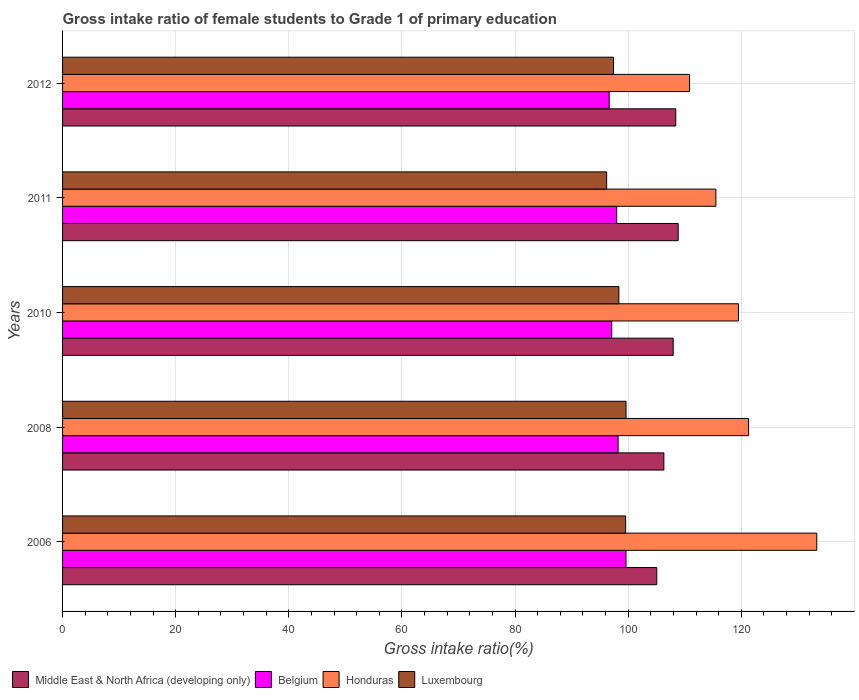How many groups of bars are there?
Provide a succinct answer. 5. Are the number of bars per tick equal to the number of legend labels?
Ensure brevity in your answer.  Yes. How many bars are there on the 2nd tick from the bottom?
Your response must be concise. 4. What is the label of the 5th group of bars from the top?
Offer a terse response. 2006. In how many cases, is the number of bars for a given year not equal to the number of legend labels?
Your answer should be compact. 0. What is the gross intake ratio in Middle East & North Africa (developing only) in 2010?
Provide a succinct answer. 107.95. Across all years, what is the maximum gross intake ratio in Honduras?
Keep it short and to the point. 133.33. Across all years, what is the minimum gross intake ratio in Luxembourg?
Offer a terse response. 96.19. In which year was the gross intake ratio in Middle East & North Africa (developing only) minimum?
Provide a succinct answer. 2006. What is the total gross intake ratio in Honduras in the graph?
Your answer should be compact. 600.43. What is the difference between the gross intake ratio in Luxembourg in 2006 and that in 2011?
Your response must be concise. 3.35. What is the difference between the gross intake ratio in Belgium in 2008 and the gross intake ratio in Honduras in 2012?
Provide a short and direct response. -12.63. What is the average gross intake ratio in Luxembourg per year?
Keep it short and to the point. 98.21. In the year 2006, what is the difference between the gross intake ratio in Belgium and gross intake ratio in Honduras?
Make the answer very short. -33.73. In how many years, is the gross intake ratio in Luxembourg greater than 92 %?
Keep it short and to the point. 5. What is the ratio of the gross intake ratio in Luxembourg in 2008 to that in 2011?
Keep it short and to the point. 1.04. Is the difference between the gross intake ratio in Belgium in 2010 and 2012 greater than the difference between the gross intake ratio in Honduras in 2010 and 2012?
Provide a short and direct response. No. What is the difference between the highest and the second highest gross intake ratio in Luxembourg?
Keep it short and to the point. 0.07. What is the difference between the highest and the lowest gross intake ratio in Belgium?
Your answer should be compact. 2.97. In how many years, is the gross intake ratio in Middle East & North Africa (developing only) greater than the average gross intake ratio in Middle East & North Africa (developing only) taken over all years?
Provide a short and direct response. 3. Is the sum of the gross intake ratio in Luxembourg in 2008 and 2010 greater than the maximum gross intake ratio in Belgium across all years?
Your answer should be very brief. Yes. What does the 1st bar from the top in 2006 represents?
Provide a short and direct response. Luxembourg. What does the 1st bar from the bottom in 2012 represents?
Offer a terse response. Middle East & North Africa (developing only). Is it the case that in every year, the sum of the gross intake ratio in Middle East & North Africa (developing only) and gross intake ratio in Honduras is greater than the gross intake ratio in Belgium?
Your answer should be compact. Yes. How many bars are there?
Your answer should be very brief. 20. What is the difference between two consecutive major ticks on the X-axis?
Give a very brief answer. 20. Does the graph contain grids?
Make the answer very short. Yes. How many legend labels are there?
Provide a short and direct response. 4. How are the legend labels stacked?
Your response must be concise. Horizontal. What is the title of the graph?
Make the answer very short. Gross intake ratio of female students to Grade 1 of primary education. What is the label or title of the X-axis?
Your answer should be compact. Gross intake ratio(%). What is the Gross intake ratio(%) of Middle East & North Africa (developing only) in 2006?
Keep it short and to the point. 105.05. What is the Gross intake ratio(%) in Belgium in 2006?
Provide a succinct answer. 99.61. What is the Gross intake ratio(%) of Honduras in 2006?
Your answer should be very brief. 133.33. What is the Gross intake ratio(%) of Luxembourg in 2006?
Your response must be concise. 99.54. What is the Gross intake ratio(%) of Middle East & North Africa (developing only) in 2008?
Keep it short and to the point. 106.3. What is the Gross intake ratio(%) in Belgium in 2008?
Ensure brevity in your answer.  98.21. What is the Gross intake ratio(%) of Honduras in 2008?
Ensure brevity in your answer.  121.28. What is the Gross intake ratio(%) in Luxembourg in 2008?
Offer a very short reply. 99.61. What is the Gross intake ratio(%) in Middle East & North Africa (developing only) in 2010?
Make the answer very short. 107.95. What is the Gross intake ratio(%) in Belgium in 2010?
Provide a succinct answer. 97.08. What is the Gross intake ratio(%) in Honduras in 2010?
Your answer should be compact. 119.48. What is the Gross intake ratio(%) in Luxembourg in 2010?
Your answer should be compact. 98.35. What is the Gross intake ratio(%) of Middle East & North Africa (developing only) in 2011?
Offer a very short reply. 108.83. What is the Gross intake ratio(%) in Belgium in 2011?
Ensure brevity in your answer.  97.96. What is the Gross intake ratio(%) of Honduras in 2011?
Your response must be concise. 115.49. What is the Gross intake ratio(%) in Luxembourg in 2011?
Your answer should be very brief. 96.19. What is the Gross intake ratio(%) of Middle East & North Africa (developing only) in 2012?
Provide a succinct answer. 108.4. What is the Gross intake ratio(%) in Belgium in 2012?
Offer a very short reply. 96.63. What is the Gross intake ratio(%) of Honduras in 2012?
Your response must be concise. 110.84. What is the Gross intake ratio(%) of Luxembourg in 2012?
Ensure brevity in your answer.  97.39. Across all years, what is the maximum Gross intake ratio(%) in Middle East & North Africa (developing only)?
Provide a succinct answer. 108.83. Across all years, what is the maximum Gross intake ratio(%) of Belgium?
Your answer should be very brief. 99.61. Across all years, what is the maximum Gross intake ratio(%) of Honduras?
Keep it short and to the point. 133.33. Across all years, what is the maximum Gross intake ratio(%) in Luxembourg?
Offer a terse response. 99.61. Across all years, what is the minimum Gross intake ratio(%) of Middle East & North Africa (developing only)?
Offer a terse response. 105.05. Across all years, what is the minimum Gross intake ratio(%) in Belgium?
Ensure brevity in your answer.  96.63. Across all years, what is the minimum Gross intake ratio(%) of Honduras?
Your answer should be very brief. 110.84. Across all years, what is the minimum Gross intake ratio(%) in Luxembourg?
Your response must be concise. 96.19. What is the total Gross intake ratio(%) of Middle East & North Africa (developing only) in the graph?
Offer a terse response. 536.52. What is the total Gross intake ratio(%) in Belgium in the graph?
Give a very brief answer. 489.49. What is the total Gross intake ratio(%) of Honduras in the graph?
Offer a terse response. 600.43. What is the total Gross intake ratio(%) of Luxembourg in the graph?
Your answer should be very brief. 491.07. What is the difference between the Gross intake ratio(%) in Middle East & North Africa (developing only) in 2006 and that in 2008?
Offer a very short reply. -1.25. What is the difference between the Gross intake ratio(%) in Belgium in 2006 and that in 2008?
Provide a succinct answer. 1.4. What is the difference between the Gross intake ratio(%) in Honduras in 2006 and that in 2008?
Make the answer very short. 12.06. What is the difference between the Gross intake ratio(%) in Luxembourg in 2006 and that in 2008?
Provide a short and direct response. -0.07. What is the difference between the Gross intake ratio(%) in Middle East & North Africa (developing only) in 2006 and that in 2010?
Offer a terse response. -2.9. What is the difference between the Gross intake ratio(%) of Belgium in 2006 and that in 2010?
Your answer should be very brief. 2.53. What is the difference between the Gross intake ratio(%) of Honduras in 2006 and that in 2010?
Keep it short and to the point. 13.85. What is the difference between the Gross intake ratio(%) of Luxembourg in 2006 and that in 2010?
Your answer should be very brief. 1.19. What is the difference between the Gross intake ratio(%) in Middle East & North Africa (developing only) in 2006 and that in 2011?
Offer a terse response. -3.78. What is the difference between the Gross intake ratio(%) in Belgium in 2006 and that in 2011?
Your answer should be compact. 1.64. What is the difference between the Gross intake ratio(%) of Honduras in 2006 and that in 2011?
Offer a terse response. 17.84. What is the difference between the Gross intake ratio(%) of Luxembourg in 2006 and that in 2011?
Provide a short and direct response. 3.35. What is the difference between the Gross intake ratio(%) in Middle East & North Africa (developing only) in 2006 and that in 2012?
Your answer should be very brief. -3.36. What is the difference between the Gross intake ratio(%) of Belgium in 2006 and that in 2012?
Offer a terse response. 2.97. What is the difference between the Gross intake ratio(%) in Honduras in 2006 and that in 2012?
Offer a terse response. 22.49. What is the difference between the Gross intake ratio(%) of Luxembourg in 2006 and that in 2012?
Offer a terse response. 2.15. What is the difference between the Gross intake ratio(%) in Middle East & North Africa (developing only) in 2008 and that in 2010?
Give a very brief answer. -1.65. What is the difference between the Gross intake ratio(%) in Belgium in 2008 and that in 2010?
Your answer should be compact. 1.13. What is the difference between the Gross intake ratio(%) in Honduras in 2008 and that in 2010?
Your answer should be compact. 1.79. What is the difference between the Gross intake ratio(%) of Luxembourg in 2008 and that in 2010?
Ensure brevity in your answer.  1.26. What is the difference between the Gross intake ratio(%) of Middle East & North Africa (developing only) in 2008 and that in 2011?
Make the answer very short. -2.53. What is the difference between the Gross intake ratio(%) in Belgium in 2008 and that in 2011?
Your answer should be very brief. 0.25. What is the difference between the Gross intake ratio(%) in Honduras in 2008 and that in 2011?
Provide a short and direct response. 5.79. What is the difference between the Gross intake ratio(%) of Luxembourg in 2008 and that in 2011?
Your answer should be compact. 3.42. What is the difference between the Gross intake ratio(%) in Middle East & North Africa (developing only) in 2008 and that in 2012?
Your answer should be compact. -2.1. What is the difference between the Gross intake ratio(%) of Belgium in 2008 and that in 2012?
Offer a terse response. 1.58. What is the difference between the Gross intake ratio(%) of Honduras in 2008 and that in 2012?
Offer a terse response. 10.44. What is the difference between the Gross intake ratio(%) of Luxembourg in 2008 and that in 2012?
Make the answer very short. 2.22. What is the difference between the Gross intake ratio(%) in Middle East & North Africa (developing only) in 2010 and that in 2011?
Offer a terse response. -0.88. What is the difference between the Gross intake ratio(%) of Belgium in 2010 and that in 2011?
Your response must be concise. -0.88. What is the difference between the Gross intake ratio(%) in Honduras in 2010 and that in 2011?
Offer a terse response. 3.99. What is the difference between the Gross intake ratio(%) of Luxembourg in 2010 and that in 2011?
Your answer should be compact. 2.16. What is the difference between the Gross intake ratio(%) in Middle East & North Africa (developing only) in 2010 and that in 2012?
Ensure brevity in your answer.  -0.45. What is the difference between the Gross intake ratio(%) in Belgium in 2010 and that in 2012?
Provide a succinct answer. 0.45. What is the difference between the Gross intake ratio(%) of Honduras in 2010 and that in 2012?
Give a very brief answer. 8.65. What is the difference between the Gross intake ratio(%) in Luxembourg in 2010 and that in 2012?
Your answer should be very brief. 0.95. What is the difference between the Gross intake ratio(%) of Middle East & North Africa (developing only) in 2011 and that in 2012?
Your response must be concise. 0.43. What is the difference between the Gross intake ratio(%) in Belgium in 2011 and that in 2012?
Keep it short and to the point. 1.33. What is the difference between the Gross intake ratio(%) of Honduras in 2011 and that in 2012?
Provide a succinct answer. 4.65. What is the difference between the Gross intake ratio(%) in Luxembourg in 2011 and that in 2012?
Offer a very short reply. -1.21. What is the difference between the Gross intake ratio(%) of Middle East & North Africa (developing only) in 2006 and the Gross intake ratio(%) of Belgium in 2008?
Provide a succinct answer. 6.84. What is the difference between the Gross intake ratio(%) in Middle East & North Africa (developing only) in 2006 and the Gross intake ratio(%) in Honduras in 2008?
Keep it short and to the point. -16.23. What is the difference between the Gross intake ratio(%) in Middle East & North Africa (developing only) in 2006 and the Gross intake ratio(%) in Luxembourg in 2008?
Your response must be concise. 5.43. What is the difference between the Gross intake ratio(%) of Belgium in 2006 and the Gross intake ratio(%) of Honduras in 2008?
Your answer should be very brief. -21.67. What is the difference between the Gross intake ratio(%) in Belgium in 2006 and the Gross intake ratio(%) in Luxembourg in 2008?
Your answer should be compact. -0. What is the difference between the Gross intake ratio(%) in Honduras in 2006 and the Gross intake ratio(%) in Luxembourg in 2008?
Offer a terse response. 33.72. What is the difference between the Gross intake ratio(%) in Middle East & North Africa (developing only) in 2006 and the Gross intake ratio(%) in Belgium in 2010?
Your response must be concise. 7.96. What is the difference between the Gross intake ratio(%) in Middle East & North Africa (developing only) in 2006 and the Gross intake ratio(%) in Honduras in 2010?
Offer a very short reply. -14.44. What is the difference between the Gross intake ratio(%) of Middle East & North Africa (developing only) in 2006 and the Gross intake ratio(%) of Luxembourg in 2010?
Your response must be concise. 6.7. What is the difference between the Gross intake ratio(%) in Belgium in 2006 and the Gross intake ratio(%) in Honduras in 2010?
Provide a short and direct response. -19.88. What is the difference between the Gross intake ratio(%) in Belgium in 2006 and the Gross intake ratio(%) in Luxembourg in 2010?
Your response must be concise. 1.26. What is the difference between the Gross intake ratio(%) of Honduras in 2006 and the Gross intake ratio(%) of Luxembourg in 2010?
Keep it short and to the point. 34.99. What is the difference between the Gross intake ratio(%) of Middle East & North Africa (developing only) in 2006 and the Gross intake ratio(%) of Belgium in 2011?
Give a very brief answer. 7.08. What is the difference between the Gross intake ratio(%) in Middle East & North Africa (developing only) in 2006 and the Gross intake ratio(%) in Honduras in 2011?
Offer a very short reply. -10.45. What is the difference between the Gross intake ratio(%) of Middle East & North Africa (developing only) in 2006 and the Gross intake ratio(%) of Luxembourg in 2011?
Your answer should be very brief. 8.86. What is the difference between the Gross intake ratio(%) of Belgium in 2006 and the Gross intake ratio(%) of Honduras in 2011?
Provide a succinct answer. -15.89. What is the difference between the Gross intake ratio(%) in Belgium in 2006 and the Gross intake ratio(%) in Luxembourg in 2011?
Offer a very short reply. 3.42. What is the difference between the Gross intake ratio(%) of Honduras in 2006 and the Gross intake ratio(%) of Luxembourg in 2011?
Provide a short and direct response. 37.15. What is the difference between the Gross intake ratio(%) of Middle East & North Africa (developing only) in 2006 and the Gross intake ratio(%) of Belgium in 2012?
Your answer should be very brief. 8.41. What is the difference between the Gross intake ratio(%) in Middle East & North Africa (developing only) in 2006 and the Gross intake ratio(%) in Honduras in 2012?
Offer a very short reply. -5.79. What is the difference between the Gross intake ratio(%) in Middle East & North Africa (developing only) in 2006 and the Gross intake ratio(%) in Luxembourg in 2012?
Your answer should be compact. 7.65. What is the difference between the Gross intake ratio(%) in Belgium in 2006 and the Gross intake ratio(%) in Honduras in 2012?
Your answer should be very brief. -11.23. What is the difference between the Gross intake ratio(%) of Belgium in 2006 and the Gross intake ratio(%) of Luxembourg in 2012?
Your answer should be very brief. 2.21. What is the difference between the Gross intake ratio(%) in Honduras in 2006 and the Gross intake ratio(%) in Luxembourg in 2012?
Your response must be concise. 35.94. What is the difference between the Gross intake ratio(%) of Middle East & North Africa (developing only) in 2008 and the Gross intake ratio(%) of Belgium in 2010?
Ensure brevity in your answer.  9.22. What is the difference between the Gross intake ratio(%) in Middle East & North Africa (developing only) in 2008 and the Gross intake ratio(%) in Honduras in 2010?
Offer a terse response. -13.19. What is the difference between the Gross intake ratio(%) in Middle East & North Africa (developing only) in 2008 and the Gross intake ratio(%) in Luxembourg in 2010?
Provide a succinct answer. 7.95. What is the difference between the Gross intake ratio(%) in Belgium in 2008 and the Gross intake ratio(%) in Honduras in 2010?
Your answer should be compact. -21.28. What is the difference between the Gross intake ratio(%) in Belgium in 2008 and the Gross intake ratio(%) in Luxembourg in 2010?
Offer a terse response. -0.14. What is the difference between the Gross intake ratio(%) of Honduras in 2008 and the Gross intake ratio(%) of Luxembourg in 2010?
Keep it short and to the point. 22.93. What is the difference between the Gross intake ratio(%) of Middle East & North Africa (developing only) in 2008 and the Gross intake ratio(%) of Belgium in 2011?
Offer a very short reply. 8.34. What is the difference between the Gross intake ratio(%) of Middle East & North Africa (developing only) in 2008 and the Gross intake ratio(%) of Honduras in 2011?
Make the answer very short. -9.19. What is the difference between the Gross intake ratio(%) of Middle East & North Africa (developing only) in 2008 and the Gross intake ratio(%) of Luxembourg in 2011?
Your response must be concise. 10.11. What is the difference between the Gross intake ratio(%) in Belgium in 2008 and the Gross intake ratio(%) in Honduras in 2011?
Ensure brevity in your answer.  -17.28. What is the difference between the Gross intake ratio(%) of Belgium in 2008 and the Gross intake ratio(%) of Luxembourg in 2011?
Your answer should be very brief. 2.02. What is the difference between the Gross intake ratio(%) in Honduras in 2008 and the Gross intake ratio(%) in Luxembourg in 2011?
Provide a succinct answer. 25.09. What is the difference between the Gross intake ratio(%) of Middle East & North Africa (developing only) in 2008 and the Gross intake ratio(%) of Belgium in 2012?
Make the answer very short. 9.67. What is the difference between the Gross intake ratio(%) in Middle East & North Africa (developing only) in 2008 and the Gross intake ratio(%) in Honduras in 2012?
Offer a terse response. -4.54. What is the difference between the Gross intake ratio(%) of Middle East & North Africa (developing only) in 2008 and the Gross intake ratio(%) of Luxembourg in 2012?
Offer a very short reply. 8.91. What is the difference between the Gross intake ratio(%) in Belgium in 2008 and the Gross intake ratio(%) in Honduras in 2012?
Provide a short and direct response. -12.63. What is the difference between the Gross intake ratio(%) in Belgium in 2008 and the Gross intake ratio(%) in Luxembourg in 2012?
Keep it short and to the point. 0.82. What is the difference between the Gross intake ratio(%) of Honduras in 2008 and the Gross intake ratio(%) of Luxembourg in 2012?
Ensure brevity in your answer.  23.88. What is the difference between the Gross intake ratio(%) of Middle East & North Africa (developing only) in 2010 and the Gross intake ratio(%) of Belgium in 2011?
Your answer should be compact. 9.99. What is the difference between the Gross intake ratio(%) of Middle East & North Africa (developing only) in 2010 and the Gross intake ratio(%) of Honduras in 2011?
Your answer should be compact. -7.54. What is the difference between the Gross intake ratio(%) of Middle East & North Africa (developing only) in 2010 and the Gross intake ratio(%) of Luxembourg in 2011?
Ensure brevity in your answer.  11.76. What is the difference between the Gross intake ratio(%) in Belgium in 2010 and the Gross intake ratio(%) in Honduras in 2011?
Ensure brevity in your answer.  -18.41. What is the difference between the Gross intake ratio(%) in Belgium in 2010 and the Gross intake ratio(%) in Luxembourg in 2011?
Make the answer very short. 0.89. What is the difference between the Gross intake ratio(%) in Honduras in 2010 and the Gross intake ratio(%) in Luxembourg in 2011?
Your answer should be very brief. 23.3. What is the difference between the Gross intake ratio(%) in Middle East & North Africa (developing only) in 2010 and the Gross intake ratio(%) in Belgium in 2012?
Provide a short and direct response. 11.32. What is the difference between the Gross intake ratio(%) of Middle East & North Africa (developing only) in 2010 and the Gross intake ratio(%) of Honduras in 2012?
Ensure brevity in your answer.  -2.89. What is the difference between the Gross intake ratio(%) in Middle East & North Africa (developing only) in 2010 and the Gross intake ratio(%) in Luxembourg in 2012?
Provide a succinct answer. 10.56. What is the difference between the Gross intake ratio(%) in Belgium in 2010 and the Gross intake ratio(%) in Honduras in 2012?
Make the answer very short. -13.76. What is the difference between the Gross intake ratio(%) of Belgium in 2010 and the Gross intake ratio(%) of Luxembourg in 2012?
Give a very brief answer. -0.31. What is the difference between the Gross intake ratio(%) of Honduras in 2010 and the Gross intake ratio(%) of Luxembourg in 2012?
Provide a succinct answer. 22.09. What is the difference between the Gross intake ratio(%) in Middle East & North Africa (developing only) in 2011 and the Gross intake ratio(%) in Belgium in 2012?
Your answer should be very brief. 12.2. What is the difference between the Gross intake ratio(%) in Middle East & North Africa (developing only) in 2011 and the Gross intake ratio(%) in Honduras in 2012?
Provide a short and direct response. -2.01. What is the difference between the Gross intake ratio(%) of Middle East & North Africa (developing only) in 2011 and the Gross intake ratio(%) of Luxembourg in 2012?
Make the answer very short. 11.44. What is the difference between the Gross intake ratio(%) in Belgium in 2011 and the Gross intake ratio(%) in Honduras in 2012?
Offer a very short reply. -12.88. What is the difference between the Gross intake ratio(%) in Belgium in 2011 and the Gross intake ratio(%) in Luxembourg in 2012?
Ensure brevity in your answer.  0.57. What is the difference between the Gross intake ratio(%) in Honduras in 2011 and the Gross intake ratio(%) in Luxembourg in 2012?
Provide a succinct answer. 18.1. What is the average Gross intake ratio(%) in Middle East & North Africa (developing only) per year?
Your response must be concise. 107.3. What is the average Gross intake ratio(%) in Belgium per year?
Provide a succinct answer. 97.9. What is the average Gross intake ratio(%) in Honduras per year?
Your answer should be compact. 120.09. What is the average Gross intake ratio(%) in Luxembourg per year?
Your answer should be very brief. 98.21. In the year 2006, what is the difference between the Gross intake ratio(%) of Middle East & North Africa (developing only) and Gross intake ratio(%) of Belgium?
Offer a terse response. 5.44. In the year 2006, what is the difference between the Gross intake ratio(%) in Middle East & North Africa (developing only) and Gross intake ratio(%) in Honduras?
Make the answer very short. -28.29. In the year 2006, what is the difference between the Gross intake ratio(%) of Middle East & North Africa (developing only) and Gross intake ratio(%) of Luxembourg?
Offer a very short reply. 5.51. In the year 2006, what is the difference between the Gross intake ratio(%) in Belgium and Gross intake ratio(%) in Honduras?
Offer a very short reply. -33.73. In the year 2006, what is the difference between the Gross intake ratio(%) of Belgium and Gross intake ratio(%) of Luxembourg?
Your answer should be compact. 0.07. In the year 2006, what is the difference between the Gross intake ratio(%) in Honduras and Gross intake ratio(%) in Luxembourg?
Ensure brevity in your answer.  33.79. In the year 2008, what is the difference between the Gross intake ratio(%) in Middle East & North Africa (developing only) and Gross intake ratio(%) in Belgium?
Ensure brevity in your answer.  8.09. In the year 2008, what is the difference between the Gross intake ratio(%) in Middle East & North Africa (developing only) and Gross intake ratio(%) in Honduras?
Your response must be concise. -14.98. In the year 2008, what is the difference between the Gross intake ratio(%) in Middle East & North Africa (developing only) and Gross intake ratio(%) in Luxembourg?
Keep it short and to the point. 6.69. In the year 2008, what is the difference between the Gross intake ratio(%) of Belgium and Gross intake ratio(%) of Honduras?
Your response must be concise. -23.07. In the year 2008, what is the difference between the Gross intake ratio(%) of Belgium and Gross intake ratio(%) of Luxembourg?
Provide a short and direct response. -1.4. In the year 2008, what is the difference between the Gross intake ratio(%) of Honduras and Gross intake ratio(%) of Luxembourg?
Offer a very short reply. 21.67. In the year 2010, what is the difference between the Gross intake ratio(%) in Middle East & North Africa (developing only) and Gross intake ratio(%) in Belgium?
Provide a short and direct response. 10.87. In the year 2010, what is the difference between the Gross intake ratio(%) of Middle East & North Africa (developing only) and Gross intake ratio(%) of Honduras?
Your answer should be very brief. -11.54. In the year 2010, what is the difference between the Gross intake ratio(%) in Middle East & North Africa (developing only) and Gross intake ratio(%) in Luxembourg?
Keep it short and to the point. 9.6. In the year 2010, what is the difference between the Gross intake ratio(%) in Belgium and Gross intake ratio(%) in Honduras?
Give a very brief answer. -22.4. In the year 2010, what is the difference between the Gross intake ratio(%) of Belgium and Gross intake ratio(%) of Luxembourg?
Offer a very short reply. -1.27. In the year 2010, what is the difference between the Gross intake ratio(%) of Honduras and Gross intake ratio(%) of Luxembourg?
Make the answer very short. 21.14. In the year 2011, what is the difference between the Gross intake ratio(%) in Middle East & North Africa (developing only) and Gross intake ratio(%) in Belgium?
Offer a terse response. 10.87. In the year 2011, what is the difference between the Gross intake ratio(%) of Middle East & North Africa (developing only) and Gross intake ratio(%) of Honduras?
Make the answer very short. -6.66. In the year 2011, what is the difference between the Gross intake ratio(%) in Middle East & North Africa (developing only) and Gross intake ratio(%) in Luxembourg?
Offer a terse response. 12.64. In the year 2011, what is the difference between the Gross intake ratio(%) of Belgium and Gross intake ratio(%) of Honduras?
Make the answer very short. -17.53. In the year 2011, what is the difference between the Gross intake ratio(%) of Belgium and Gross intake ratio(%) of Luxembourg?
Provide a succinct answer. 1.78. In the year 2011, what is the difference between the Gross intake ratio(%) in Honduras and Gross intake ratio(%) in Luxembourg?
Offer a terse response. 19.31. In the year 2012, what is the difference between the Gross intake ratio(%) of Middle East & North Africa (developing only) and Gross intake ratio(%) of Belgium?
Make the answer very short. 11.77. In the year 2012, what is the difference between the Gross intake ratio(%) in Middle East & North Africa (developing only) and Gross intake ratio(%) in Honduras?
Make the answer very short. -2.44. In the year 2012, what is the difference between the Gross intake ratio(%) in Middle East & North Africa (developing only) and Gross intake ratio(%) in Luxembourg?
Keep it short and to the point. 11.01. In the year 2012, what is the difference between the Gross intake ratio(%) in Belgium and Gross intake ratio(%) in Honduras?
Make the answer very short. -14.21. In the year 2012, what is the difference between the Gross intake ratio(%) in Belgium and Gross intake ratio(%) in Luxembourg?
Your response must be concise. -0.76. In the year 2012, what is the difference between the Gross intake ratio(%) in Honduras and Gross intake ratio(%) in Luxembourg?
Provide a short and direct response. 13.45. What is the ratio of the Gross intake ratio(%) in Middle East & North Africa (developing only) in 2006 to that in 2008?
Offer a very short reply. 0.99. What is the ratio of the Gross intake ratio(%) in Belgium in 2006 to that in 2008?
Provide a short and direct response. 1.01. What is the ratio of the Gross intake ratio(%) of Honduras in 2006 to that in 2008?
Ensure brevity in your answer.  1.1. What is the ratio of the Gross intake ratio(%) of Luxembourg in 2006 to that in 2008?
Your response must be concise. 1. What is the ratio of the Gross intake ratio(%) of Middle East & North Africa (developing only) in 2006 to that in 2010?
Ensure brevity in your answer.  0.97. What is the ratio of the Gross intake ratio(%) in Honduras in 2006 to that in 2010?
Provide a succinct answer. 1.12. What is the ratio of the Gross intake ratio(%) in Luxembourg in 2006 to that in 2010?
Offer a very short reply. 1.01. What is the ratio of the Gross intake ratio(%) of Middle East & North Africa (developing only) in 2006 to that in 2011?
Offer a very short reply. 0.97. What is the ratio of the Gross intake ratio(%) in Belgium in 2006 to that in 2011?
Offer a very short reply. 1.02. What is the ratio of the Gross intake ratio(%) in Honduras in 2006 to that in 2011?
Your answer should be very brief. 1.15. What is the ratio of the Gross intake ratio(%) in Luxembourg in 2006 to that in 2011?
Your answer should be compact. 1.03. What is the ratio of the Gross intake ratio(%) in Middle East & North Africa (developing only) in 2006 to that in 2012?
Your answer should be very brief. 0.97. What is the ratio of the Gross intake ratio(%) in Belgium in 2006 to that in 2012?
Keep it short and to the point. 1.03. What is the ratio of the Gross intake ratio(%) in Honduras in 2006 to that in 2012?
Make the answer very short. 1.2. What is the ratio of the Gross intake ratio(%) in Luxembourg in 2006 to that in 2012?
Your response must be concise. 1.02. What is the ratio of the Gross intake ratio(%) in Middle East & North Africa (developing only) in 2008 to that in 2010?
Offer a very short reply. 0.98. What is the ratio of the Gross intake ratio(%) of Belgium in 2008 to that in 2010?
Offer a very short reply. 1.01. What is the ratio of the Gross intake ratio(%) of Honduras in 2008 to that in 2010?
Make the answer very short. 1.01. What is the ratio of the Gross intake ratio(%) in Luxembourg in 2008 to that in 2010?
Provide a short and direct response. 1.01. What is the ratio of the Gross intake ratio(%) of Middle East & North Africa (developing only) in 2008 to that in 2011?
Make the answer very short. 0.98. What is the ratio of the Gross intake ratio(%) in Honduras in 2008 to that in 2011?
Your answer should be compact. 1.05. What is the ratio of the Gross intake ratio(%) of Luxembourg in 2008 to that in 2011?
Keep it short and to the point. 1.04. What is the ratio of the Gross intake ratio(%) in Middle East & North Africa (developing only) in 2008 to that in 2012?
Your response must be concise. 0.98. What is the ratio of the Gross intake ratio(%) in Belgium in 2008 to that in 2012?
Offer a very short reply. 1.02. What is the ratio of the Gross intake ratio(%) of Honduras in 2008 to that in 2012?
Offer a terse response. 1.09. What is the ratio of the Gross intake ratio(%) in Luxembourg in 2008 to that in 2012?
Your answer should be compact. 1.02. What is the ratio of the Gross intake ratio(%) in Belgium in 2010 to that in 2011?
Make the answer very short. 0.99. What is the ratio of the Gross intake ratio(%) in Honduras in 2010 to that in 2011?
Give a very brief answer. 1.03. What is the ratio of the Gross intake ratio(%) of Luxembourg in 2010 to that in 2011?
Your response must be concise. 1.02. What is the ratio of the Gross intake ratio(%) in Belgium in 2010 to that in 2012?
Offer a very short reply. 1. What is the ratio of the Gross intake ratio(%) in Honduras in 2010 to that in 2012?
Provide a succinct answer. 1.08. What is the ratio of the Gross intake ratio(%) in Luxembourg in 2010 to that in 2012?
Your answer should be very brief. 1.01. What is the ratio of the Gross intake ratio(%) in Middle East & North Africa (developing only) in 2011 to that in 2012?
Provide a short and direct response. 1. What is the ratio of the Gross intake ratio(%) in Belgium in 2011 to that in 2012?
Ensure brevity in your answer.  1.01. What is the ratio of the Gross intake ratio(%) in Honduras in 2011 to that in 2012?
Make the answer very short. 1.04. What is the ratio of the Gross intake ratio(%) in Luxembourg in 2011 to that in 2012?
Give a very brief answer. 0.99. What is the difference between the highest and the second highest Gross intake ratio(%) of Middle East & North Africa (developing only)?
Provide a succinct answer. 0.43. What is the difference between the highest and the second highest Gross intake ratio(%) in Belgium?
Offer a terse response. 1.4. What is the difference between the highest and the second highest Gross intake ratio(%) of Honduras?
Your answer should be very brief. 12.06. What is the difference between the highest and the second highest Gross intake ratio(%) in Luxembourg?
Provide a short and direct response. 0.07. What is the difference between the highest and the lowest Gross intake ratio(%) in Middle East & North Africa (developing only)?
Your response must be concise. 3.78. What is the difference between the highest and the lowest Gross intake ratio(%) of Belgium?
Ensure brevity in your answer.  2.97. What is the difference between the highest and the lowest Gross intake ratio(%) in Honduras?
Offer a very short reply. 22.49. What is the difference between the highest and the lowest Gross intake ratio(%) in Luxembourg?
Offer a very short reply. 3.42. 